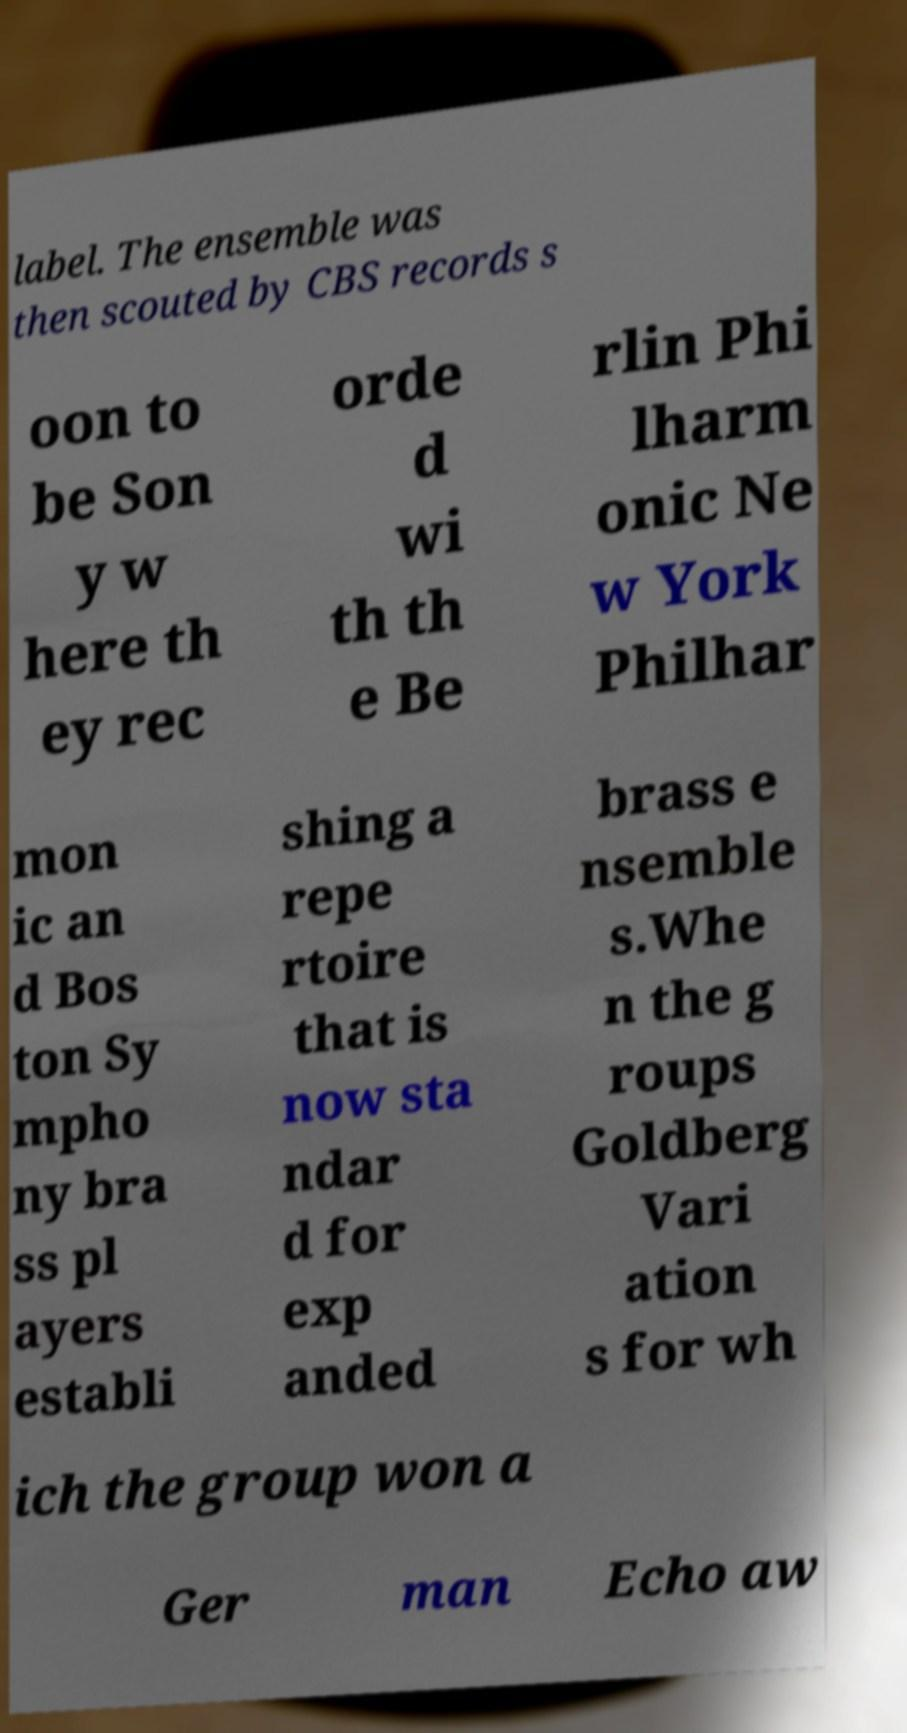There's text embedded in this image that I need extracted. Can you transcribe it verbatim? label. The ensemble was then scouted by CBS records s oon to be Son y w here th ey rec orde d wi th th e Be rlin Phi lharm onic Ne w York Philhar mon ic an d Bos ton Sy mpho ny bra ss pl ayers establi shing a repe rtoire that is now sta ndar d for exp anded brass e nsemble s.Whe n the g roups Goldberg Vari ation s for wh ich the group won a Ger man Echo aw 